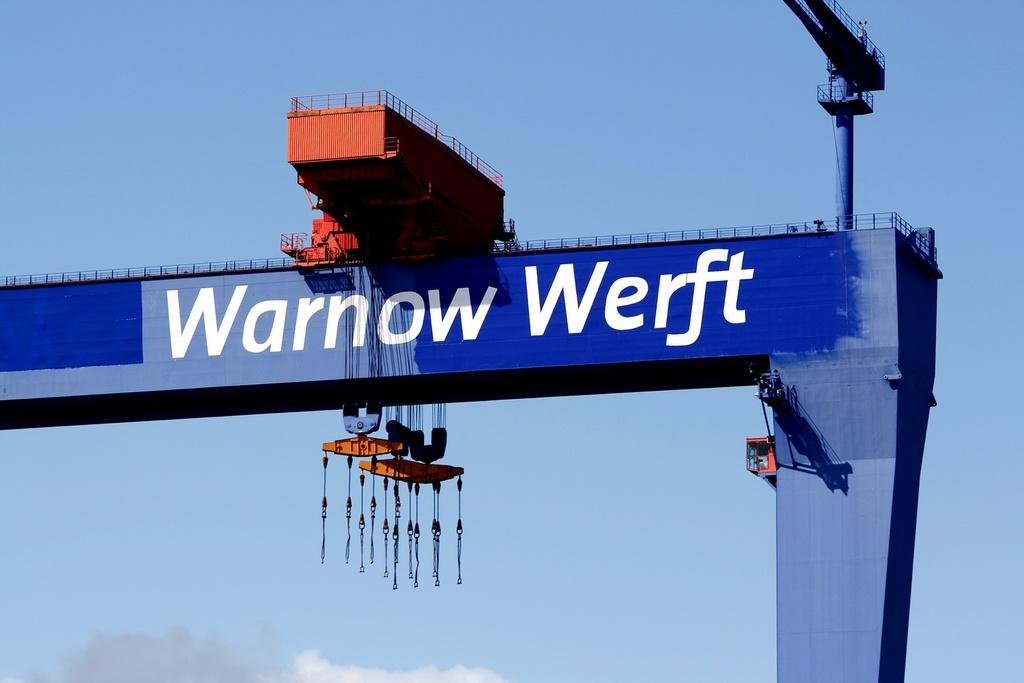<image>
Describe the image concisely. A crane type tool that reads Warnow Werft. 